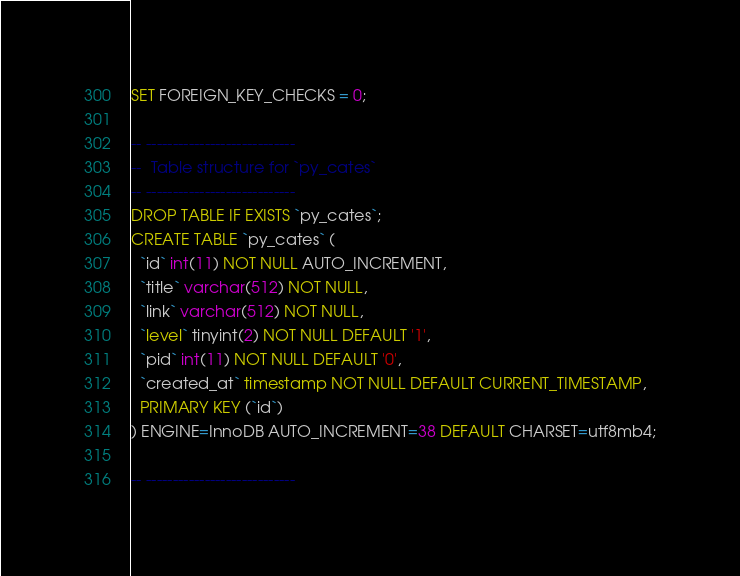Convert code to text. <code><loc_0><loc_0><loc_500><loc_500><_SQL_>SET FOREIGN_KEY_CHECKS = 0;

-- ----------------------------
--  Table structure for `py_cates`
-- ----------------------------
DROP TABLE IF EXISTS `py_cates`;
CREATE TABLE `py_cates` (
  `id` int(11) NOT NULL AUTO_INCREMENT,
  `title` varchar(512) NOT NULL,
  `link` varchar(512) NOT NULL,
  `level` tinyint(2) NOT NULL DEFAULT '1',
  `pid` int(11) NOT NULL DEFAULT '0',
  `created_at` timestamp NOT NULL DEFAULT CURRENT_TIMESTAMP,
  PRIMARY KEY (`id`)
) ENGINE=InnoDB AUTO_INCREMENT=38 DEFAULT CHARSET=utf8mb4;

-- ----------------------------</code> 